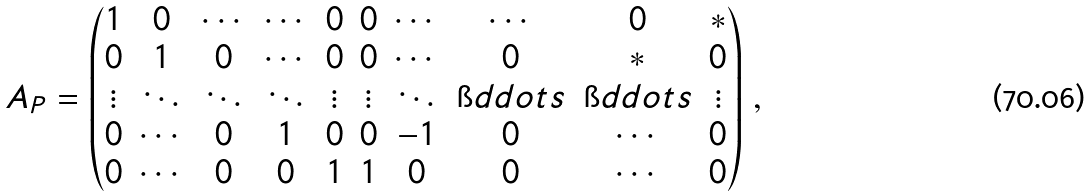<formula> <loc_0><loc_0><loc_500><loc_500>A _ { P } = \begin{pmatrix} 1 & 0 & \cdots & \cdots & 0 & 0 & \cdots & \cdots & 0 & * \\ 0 & 1 & 0 & \cdots & 0 & 0 & \cdots & 0 & * & 0 \\ \vdots & \ddots & \ddots & \ddots & \vdots & \vdots & \ddots & \i d d o t s & \i d d o t s & \vdots \\ 0 & \cdots & 0 & 1 & 0 & 0 & - 1 & 0 & \cdots & 0 \\ 0 & \cdots & 0 & 0 & 1 & 1 & 0 & 0 & \cdots & 0 \end{pmatrix} \, ,</formula> 